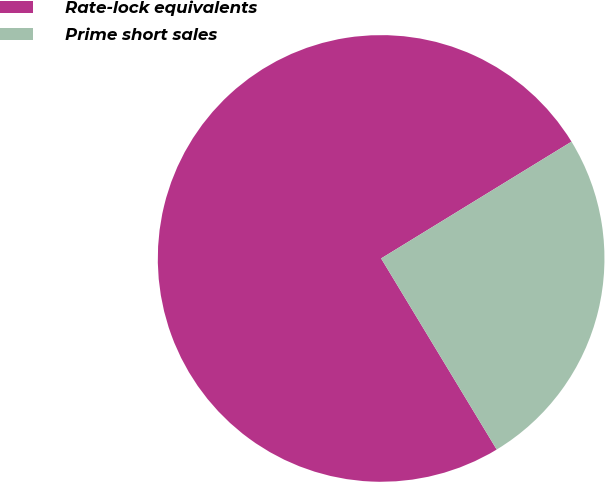Convert chart to OTSL. <chart><loc_0><loc_0><loc_500><loc_500><pie_chart><fcel>Rate-lock equivalents<fcel>Prime short sales<nl><fcel>74.9%<fcel>25.1%<nl></chart> 